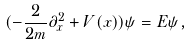<formula> <loc_0><loc_0><loc_500><loc_500>( - \frac { 2 } { 2 m } \partial _ { x } ^ { 2 } + V ( x ) ) \psi = E \psi ,</formula> 